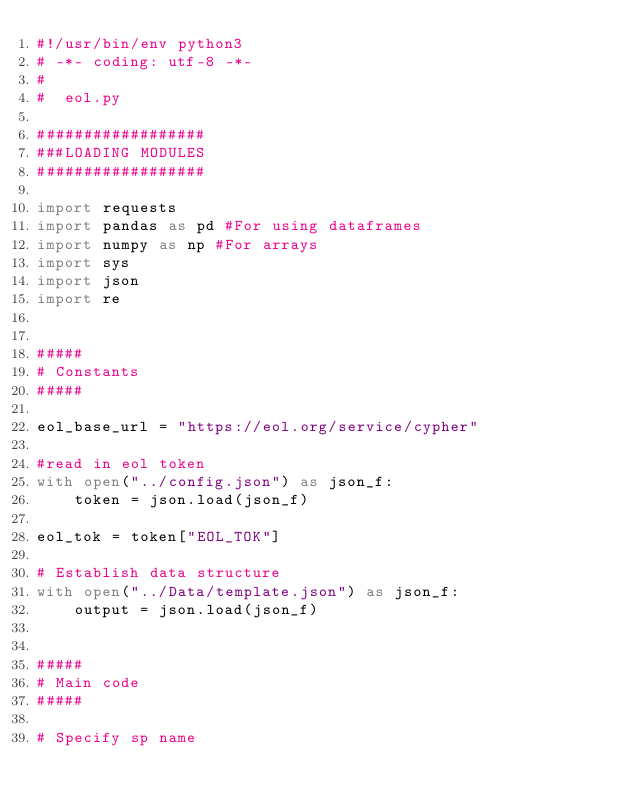Convert code to text. <code><loc_0><loc_0><loc_500><loc_500><_Python_>#!/usr/bin/env python3
# -*- coding: utf-8 -*-
#
#  eol.py

##################
###LOADING MODULES
##################

import requests
import pandas as pd #For using dataframes
import numpy as np #For arrays
import sys
import json
import re


#####
# Constants
#####

eol_base_url = "https://eol.org/service/cypher"

#read in eol token
with open("../config.json") as json_f:
	token = json.load(json_f)

eol_tok = token["EOL_TOK"]

# Establish data structure
with open("../Data/template.json") as json_f:
	output = json.load(json_f)


#####
# Main code
#####

# Specify sp name</code> 